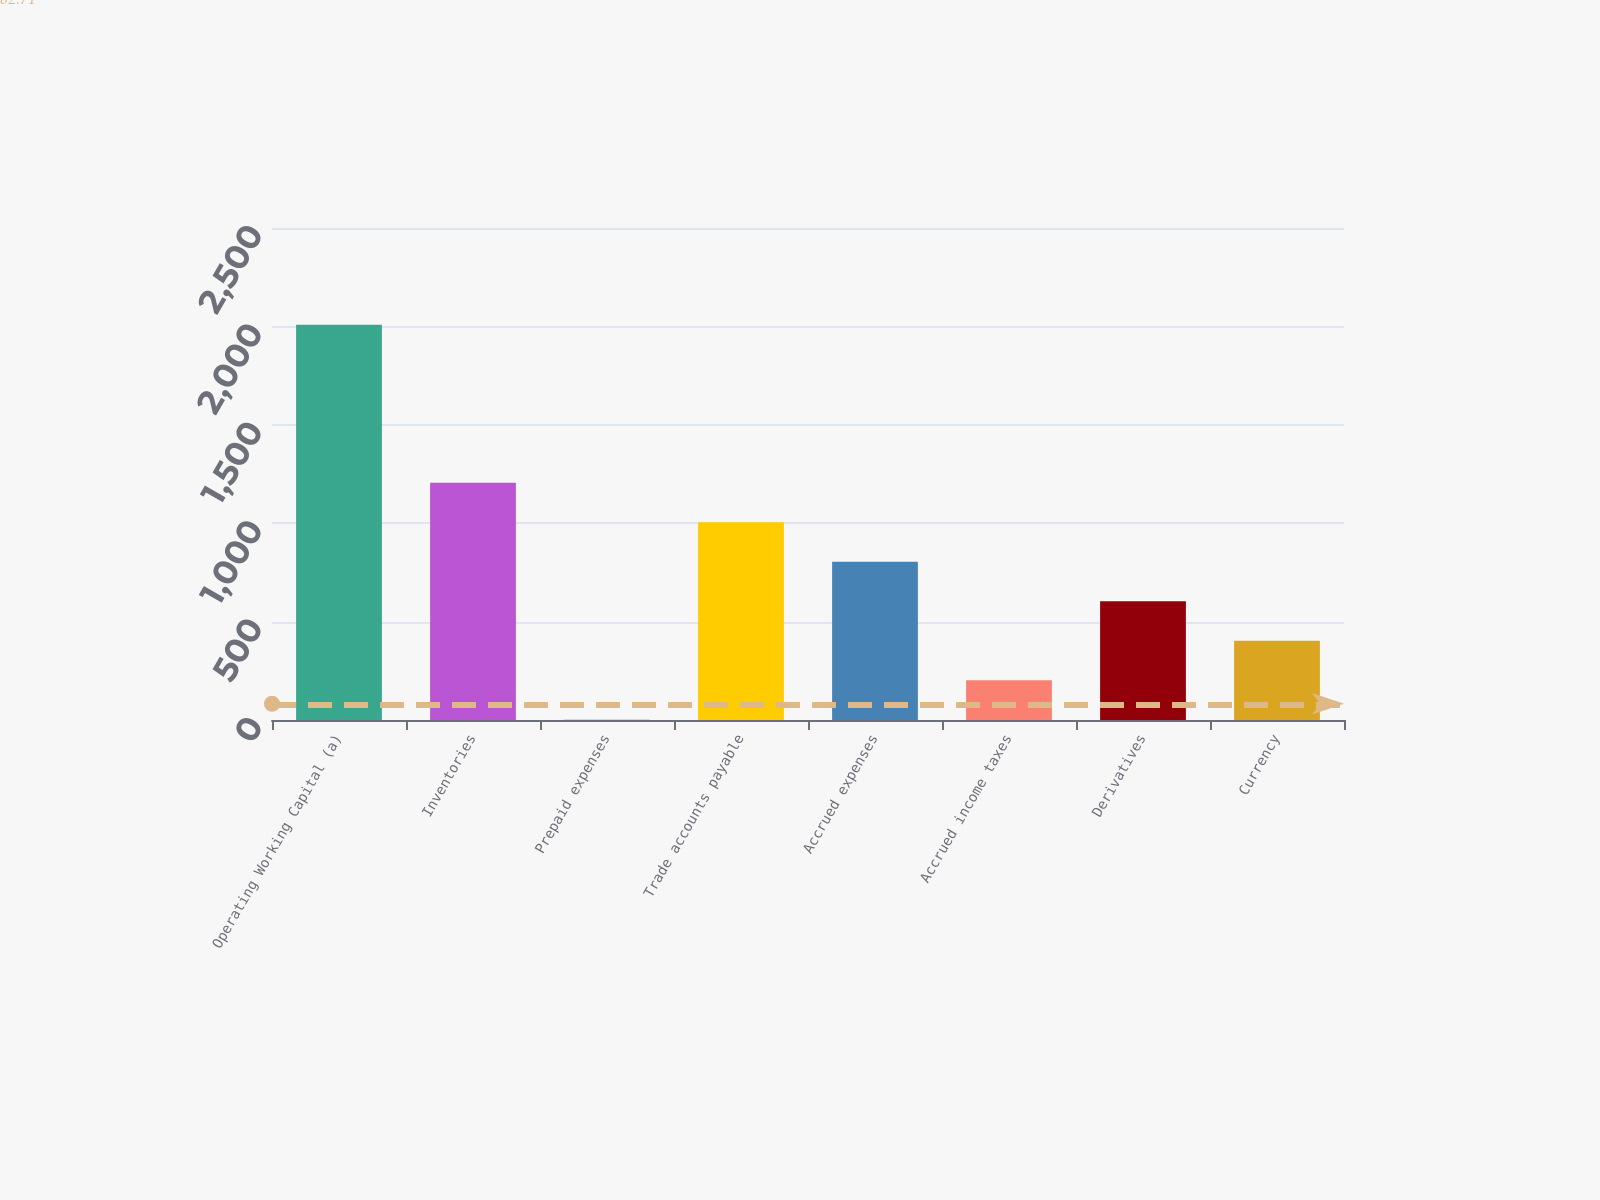<chart> <loc_0><loc_0><loc_500><loc_500><bar_chart><fcel>Operating Working Capital (a)<fcel>Inventories<fcel>Prepaid expenses<fcel>Trade accounts payable<fcel>Accrued expenses<fcel>Accrued income taxes<fcel>Derivatives<fcel>Currency<nl><fcel>2009<fcel>1205.8<fcel>1<fcel>1005<fcel>804.2<fcel>201.8<fcel>603.4<fcel>402.6<nl></chart> 